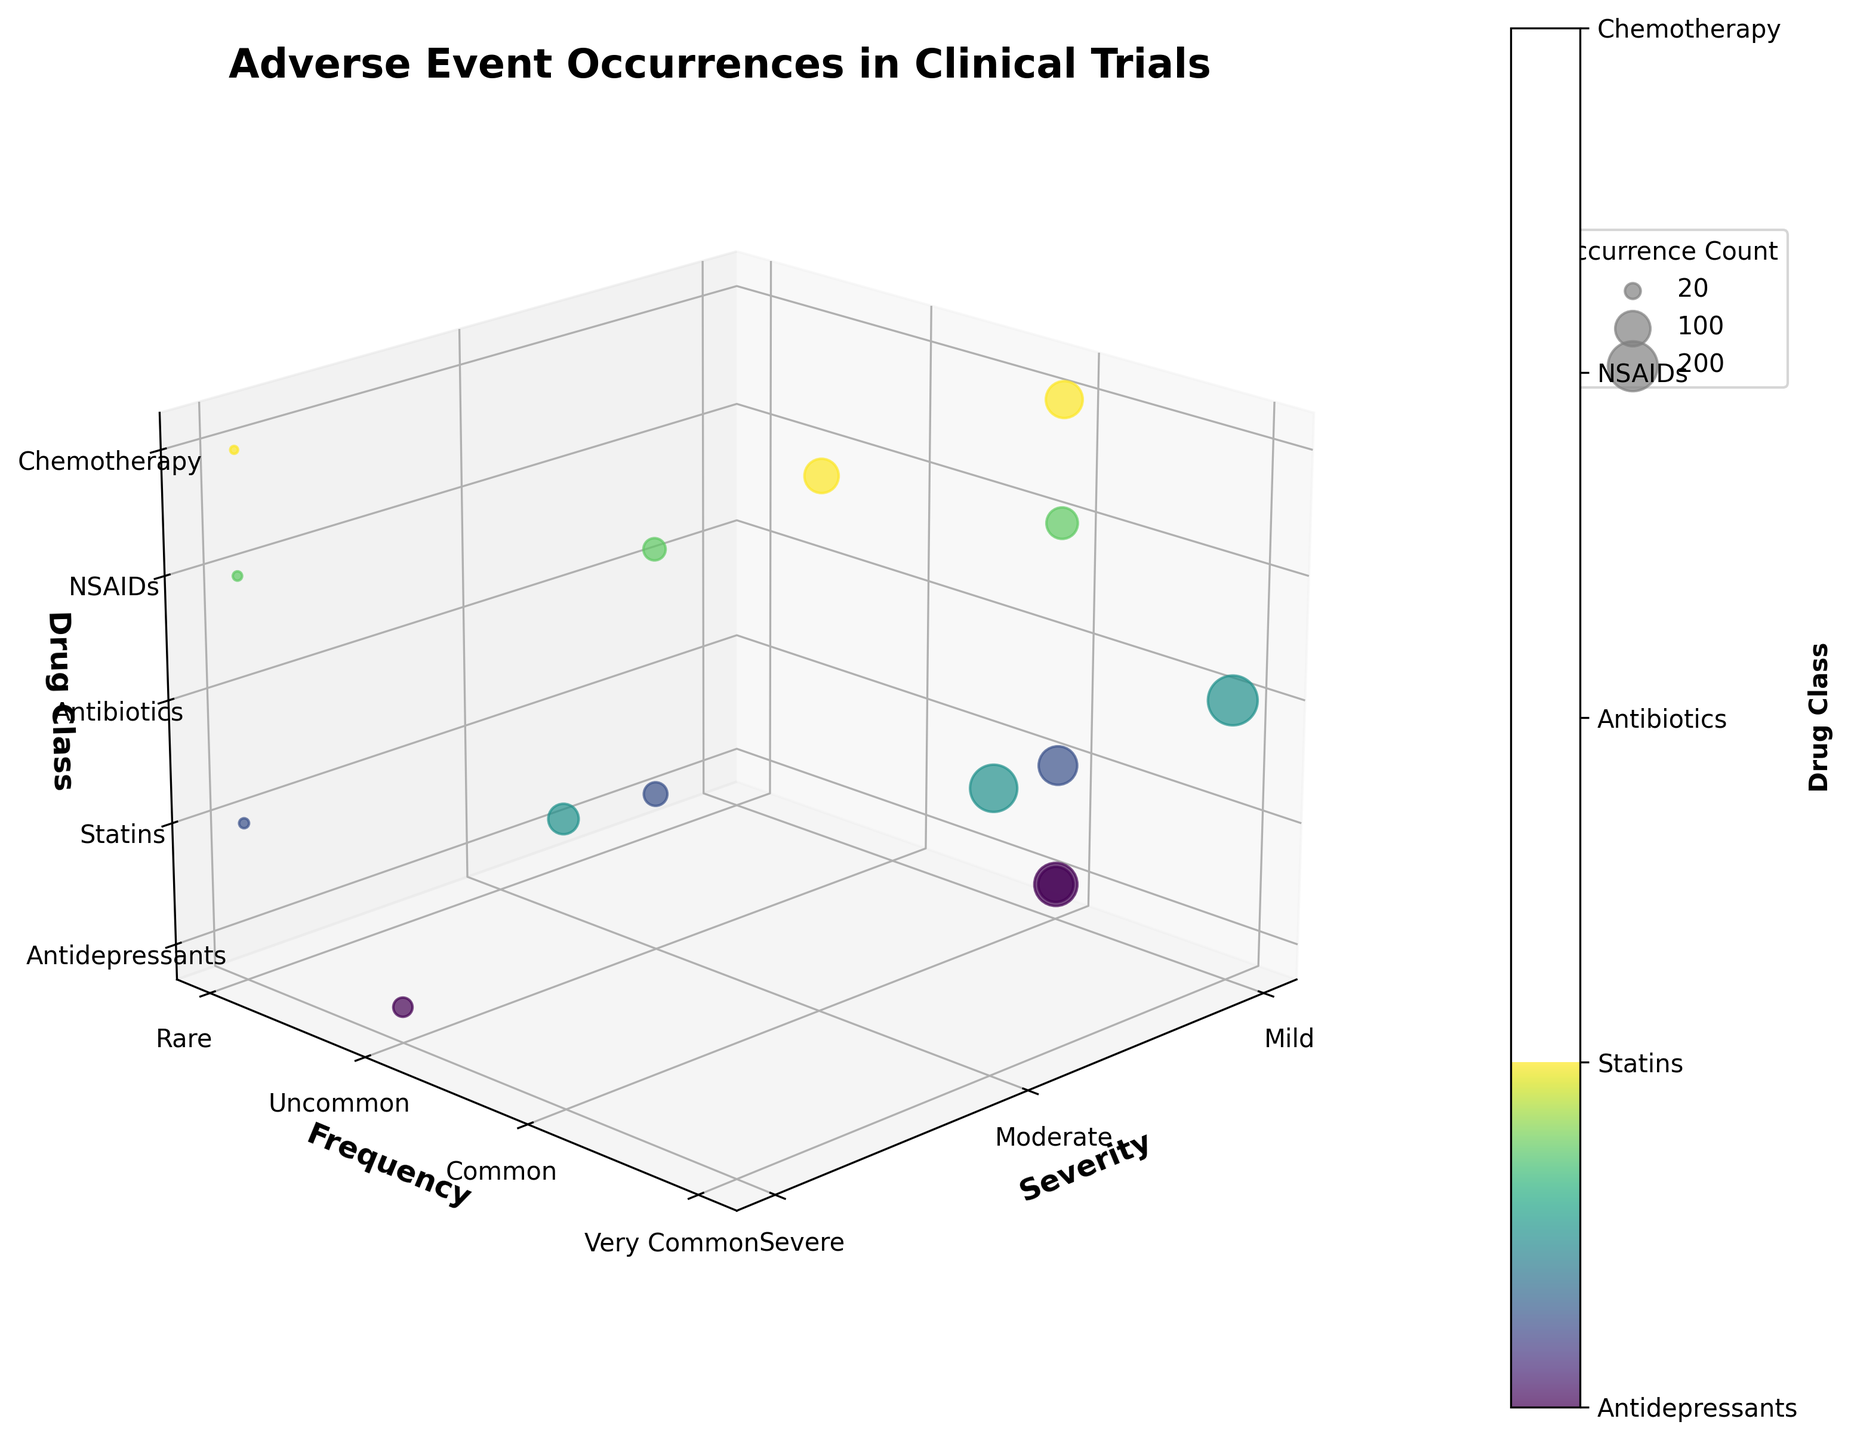What's the title of the figure? The title of the figure is usually displayed prominently at the top. For this figure, the title is clearly mentioned as 'Adverse Event Occurrences in Clinical Trials'.
Answer: Adverse Event Occurrences in Clinical Trials What does the x-axis represent in the figure? The x-axis label is shown as 'Severity', and the tick labels under the x-axis are 'Mild', 'Moderate', and 'Severe', indicating that it represents the severity of adverse events.
Answer: Severity How many data points show 'Severe' adverse events? To determine the number of data points with 'Severe' adverse events, look for all the points on the rightmost x-axis tick labeled 'Severe'. These points correspond to 'Suicidal Thoughts' for Antidepressants, 'Liver Damage' for Statins, 'Allergic Reaction' for Antibiotics, 'Kidney Damage' for NSAIDs, and 'Neutropenia' for Chemotherapy. Count the points and you get 5.
Answer: 5 Which drug class has the highest occurrence count for any single adverse event? For this, observe the size of the bubbles, since larger bubbles indicate higher occurrence counts. The largest bubble is for 'Fatigue' under Chemotherapy with an occurrence count of 200. Therefore, Chemotherapy has the highest occurrence count for a single adverse event.
Answer: Chemotherapy How do 'Common' frequencies compare between different severity levels for 'Antidepressants'? Identify all points with 'Common' frequency (y-axis labeled 'Common') within the 'Antidepressants' drug class (identified by color or z label). 'Common' frequency points for Antidepressants show 'Nausea' (Mild severity) with an occurrence count of 120, showing higher frequencies compared to that of more severe adverse events within Antidepressants. Thus, mild adverse events are more frequent.
Answer: Mild is more frequent What is the bubble with the highest z-value in the plot? The z-axis represents the drug class, ordered categorically. The highest z-value corresponds to 'Chemotherapy'. The bubble with the highest z-value indicates the conditions 'Hair Loss', 'Neutropenia', and 'Fatigue'. To identify the highest occurrence, 'Fatigue' has the largest size with a count of 200 and belongs to 'Chemotherapy'.
Answer: Fatigue Are there any drug classes that share the same adverse event, and what are they? Look for points labeled with the same adverse event name but with different z-values for drug classes. 'Nausea' appears under both 'Antidepressants' and 'Antibiotics', both labeled as 'Common' and 'Mild'.
Answer: Antidepressants and Antibiotics Which adverse events are marked as 'Very Common' and under which drug classes? Looking at the y-axis labeled 'Very Common', we find bubbles labeled 'Hair Loss' and 'Fatigue'. Both events occur under the 'Chemotherapy' drug class.
Answer: Hair Loss and Fatigue under Chemotherapy Comparatively, which frequency level ('Uncommon' or 'Common') has more 'Severe' adverse events? Count the number of bubbles under the 'Severe' x-axis label, separate by y-axis labels 'Uncommon' and 'Common'. 'Uncommon' includes 'Allergic Reaction' (Antibiotics) and 'Common' includes 'Neutropenia' (Chemotherapy). 'Uncommon' yields more 'Severe' adverse events.
Answer: Uncommon 